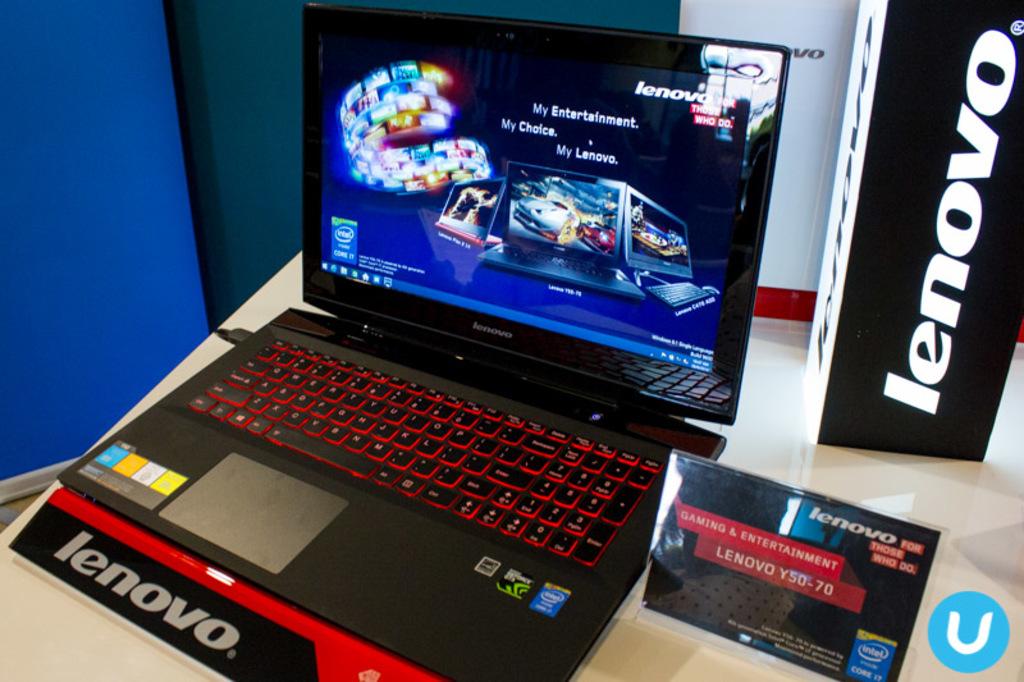What brand of computer is this?
Keep it short and to the point. Lenovo. What letter is in the corner?
Your answer should be compact. U. 